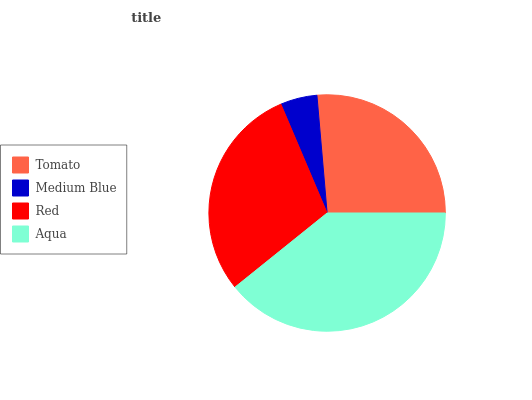Is Medium Blue the minimum?
Answer yes or no. Yes. Is Aqua the maximum?
Answer yes or no. Yes. Is Red the minimum?
Answer yes or no. No. Is Red the maximum?
Answer yes or no. No. Is Red greater than Medium Blue?
Answer yes or no. Yes. Is Medium Blue less than Red?
Answer yes or no. Yes. Is Medium Blue greater than Red?
Answer yes or no. No. Is Red less than Medium Blue?
Answer yes or no. No. Is Red the high median?
Answer yes or no. Yes. Is Tomato the low median?
Answer yes or no. Yes. Is Tomato the high median?
Answer yes or no. No. Is Medium Blue the low median?
Answer yes or no. No. 